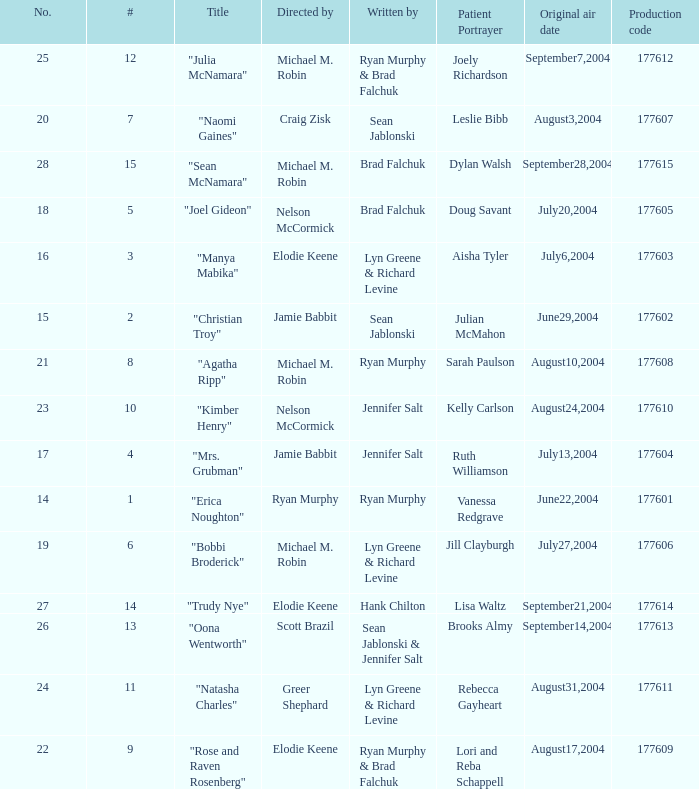Who wrote episode number 28? Brad Falchuk. 